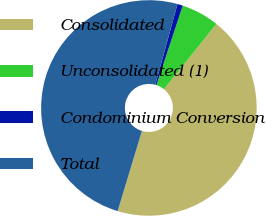Convert chart to OTSL. <chart><loc_0><loc_0><loc_500><loc_500><pie_chart><fcel>Consolidated<fcel>Unconsolidated (1)<fcel>Condominium Conversion<fcel>Total<nl><fcel>43.9%<fcel>5.69%<fcel>0.81%<fcel>49.59%<nl></chart> 